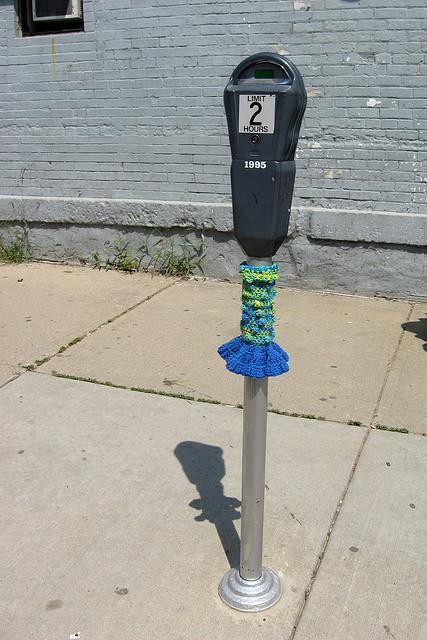How many meters are on the pole?
Give a very brief answer. 1. How many panel partitions on the blue umbrella have writing on them?
Give a very brief answer. 0. 